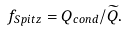Convert formula to latex. <formula><loc_0><loc_0><loc_500><loc_500>f _ { S p i t z } = Q _ { c o n d } / \widetilde { Q } .</formula> 